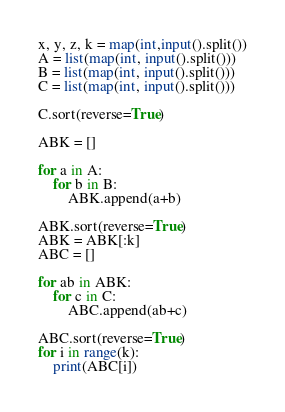Convert code to text. <code><loc_0><loc_0><loc_500><loc_500><_Python_>x, y, z, k = map(int,input().split())
A = list(map(int, input().split()))
B = list(map(int, input().split()))
C = list(map(int, input().split()))

C.sort(reverse=True)

ABK = []

for a in A:
    for b in B:
        ABK.append(a+b)

ABK.sort(reverse=True)
ABK = ABK[:k]
ABC = []

for ab in ABK:
    for c in C:
        ABC.append(ab+c)

ABC.sort(reverse=True)
for i in range(k):
    print(ABC[i])</code> 